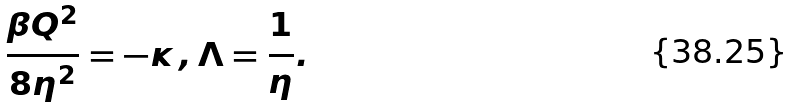<formula> <loc_0><loc_0><loc_500><loc_500>\frac { \beta Q ^ { 2 } } { 8 \eta ^ { 2 } } = - \kappa \, , \Lambda = \frac { 1 } { \eta } .</formula> 